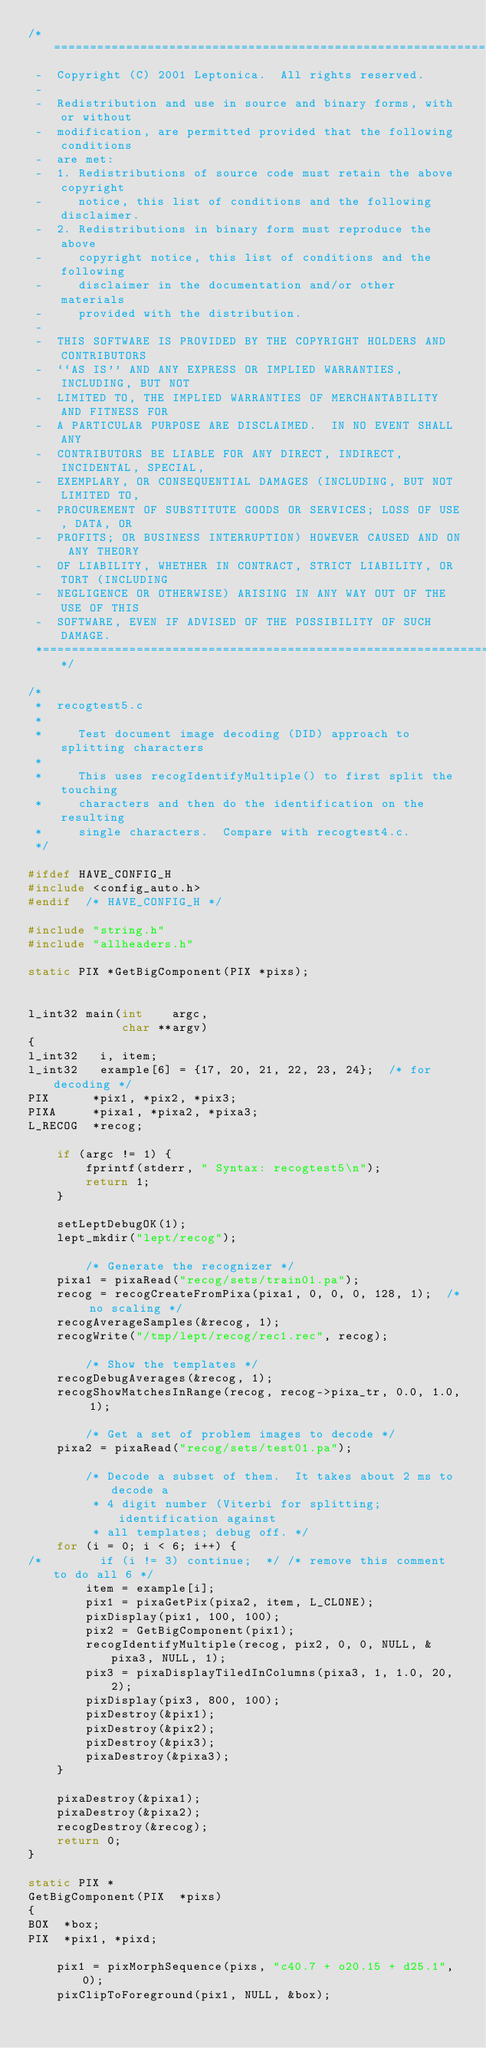Convert code to text. <code><loc_0><loc_0><loc_500><loc_500><_C_>/*====================================================================*
 -  Copyright (C) 2001 Leptonica.  All rights reserved.
 -
 -  Redistribution and use in source and binary forms, with or without
 -  modification, are permitted provided that the following conditions
 -  are met:
 -  1. Redistributions of source code must retain the above copyright
 -     notice, this list of conditions and the following disclaimer.
 -  2. Redistributions in binary form must reproduce the above
 -     copyright notice, this list of conditions and the following
 -     disclaimer in the documentation and/or other materials
 -     provided with the distribution.
 -
 -  THIS SOFTWARE IS PROVIDED BY THE COPYRIGHT HOLDERS AND CONTRIBUTORS
 -  ``AS IS'' AND ANY EXPRESS OR IMPLIED WARRANTIES, INCLUDING, BUT NOT
 -  LIMITED TO, THE IMPLIED WARRANTIES OF MERCHANTABILITY AND FITNESS FOR
 -  A PARTICULAR PURPOSE ARE DISCLAIMED.  IN NO EVENT SHALL ANY
 -  CONTRIBUTORS BE LIABLE FOR ANY DIRECT, INDIRECT, INCIDENTAL, SPECIAL,
 -  EXEMPLARY, OR CONSEQUENTIAL DAMAGES (INCLUDING, BUT NOT LIMITED TO,
 -  PROCUREMENT OF SUBSTITUTE GOODS OR SERVICES; LOSS OF USE, DATA, OR
 -  PROFITS; OR BUSINESS INTERRUPTION) HOWEVER CAUSED AND ON ANY THEORY
 -  OF LIABILITY, WHETHER IN CONTRACT, STRICT LIABILITY, OR TORT (INCLUDING
 -  NEGLIGENCE OR OTHERWISE) ARISING IN ANY WAY OUT OF THE USE OF THIS
 -  SOFTWARE, EVEN IF ADVISED OF THE POSSIBILITY OF SUCH DAMAGE.
 *====================================================================*/

/*
 *  recogtest5.c
 *
 *     Test document image decoding (DID) approach to splitting characters
 *
 *     This uses recogIdentifyMultiple() to first split the touching
 *     characters and then do the identification on the resulting
 *     single characters.  Compare with recogtest4.c.
 */

#ifdef HAVE_CONFIG_H
#include <config_auto.h>
#endif  /* HAVE_CONFIG_H */

#include "string.h"
#include "allheaders.h"

static PIX *GetBigComponent(PIX *pixs);


l_int32 main(int    argc,
             char **argv)
{
l_int32   i, item;
l_int32   example[6] = {17, 20, 21, 22, 23, 24};  /* for decoding */
PIX      *pix1, *pix2, *pix3;
PIXA     *pixa1, *pixa2, *pixa3;
L_RECOG  *recog;

    if (argc != 1) {
        fprintf(stderr, " Syntax: recogtest5\n");
        return 1;
    }

    setLeptDebugOK(1);
    lept_mkdir("lept/recog");

        /* Generate the recognizer */
    pixa1 = pixaRead("recog/sets/train01.pa");
    recog = recogCreateFromPixa(pixa1, 0, 0, 0, 128, 1);  /* no scaling */
    recogAverageSamples(&recog, 1);
    recogWrite("/tmp/lept/recog/rec1.rec", recog);

        /* Show the templates */
    recogDebugAverages(&recog, 1);
    recogShowMatchesInRange(recog, recog->pixa_tr, 0.0, 1.0, 1);

        /* Get a set of problem images to decode */
    pixa2 = pixaRead("recog/sets/test01.pa");

        /* Decode a subset of them.  It takes about 2 ms to decode a
         * 4 digit number (Viterbi for splitting; identification against
         * all templates; debug off. */
    for (i = 0; i < 6; i++) {
/*        if (i != 3) continue;  */ /* remove this comment to do all 6 */
        item = example[i];
        pix1 = pixaGetPix(pixa2, item, L_CLONE);
        pixDisplay(pix1, 100, 100);
        pix2 = GetBigComponent(pix1);
        recogIdentifyMultiple(recog, pix2, 0, 0, NULL, &pixa3, NULL, 1);
        pix3 = pixaDisplayTiledInColumns(pixa3, 1, 1.0, 20, 2);
        pixDisplay(pix3, 800, 100);
        pixDestroy(&pix1);
        pixDestroy(&pix2);
        pixDestroy(&pix3);
        pixaDestroy(&pixa3);
    }

    pixaDestroy(&pixa1);
    pixaDestroy(&pixa2);
    recogDestroy(&recog);
    return 0;
}

static PIX *
GetBigComponent(PIX  *pixs)
{
BOX  *box;
PIX  *pix1, *pixd;

    pix1 = pixMorphSequence(pixs, "c40.7 + o20.15 + d25.1", 0);
    pixClipToForeground(pix1, NULL, &box);</code> 